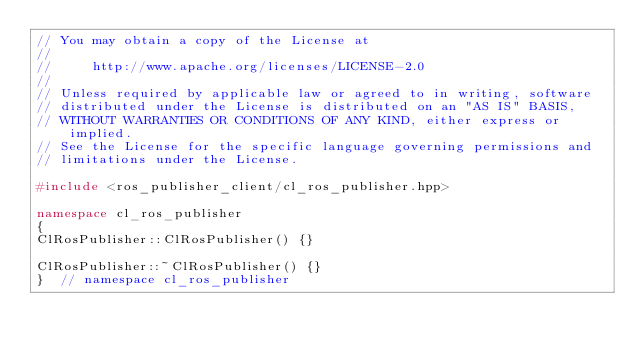<code> <loc_0><loc_0><loc_500><loc_500><_C++_>// You may obtain a copy of the License at
//
//     http://www.apache.org/licenses/LICENSE-2.0
//
// Unless required by applicable law or agreed to in writing, software
// distributed under the License is distributed on an "AS IS" BASIS,
// WITHOUT WARRANTIES OR CONDITIONS OF ANY KIND, either express or implied.
// See the License for the specific language governing permissions and
// limitations under the License.

#include <ros_publisher_client/cl_ros_publisher.hpp>

namespace cl_ros_publisher
{
ClRosPublisher::ClRosPublisher() {}

ClRosPublisher::~ClRosPublisher() {}
}  // namespace cl_ros_publisher
</code> 